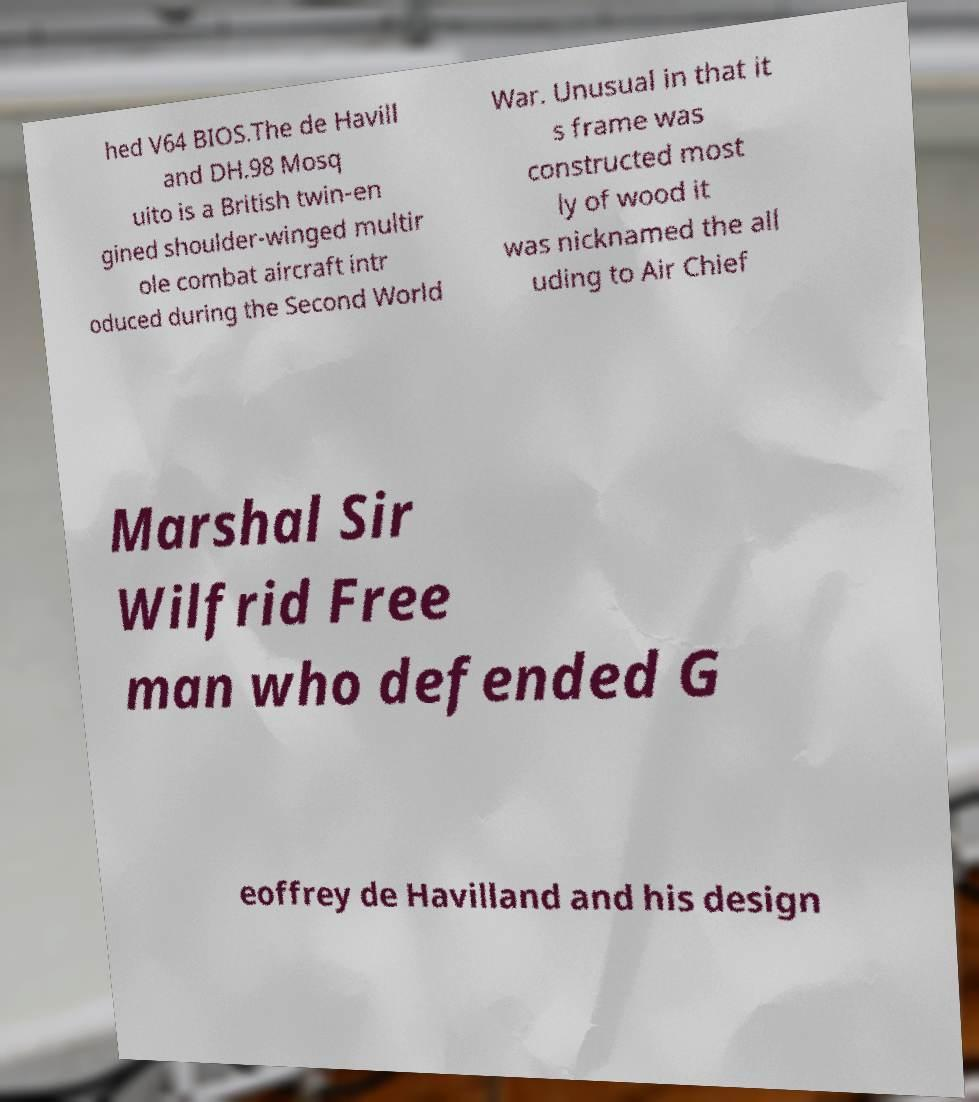There's text embedded in this image that I need extracted. Can you transcribe it verbatim? hed V64 BIOS.The de Havill and DH.98 Mosq uito is a British twin-en gined shoulder-winged multir ole combat aircraft intr oduced during the Second World War. Unusual in that it s frame was constructed most ly of wood it was nicknamed the all uding to Air Chief Marshal Sir Wilfrid Free man who defended G eoffrey de Havilland and his design 